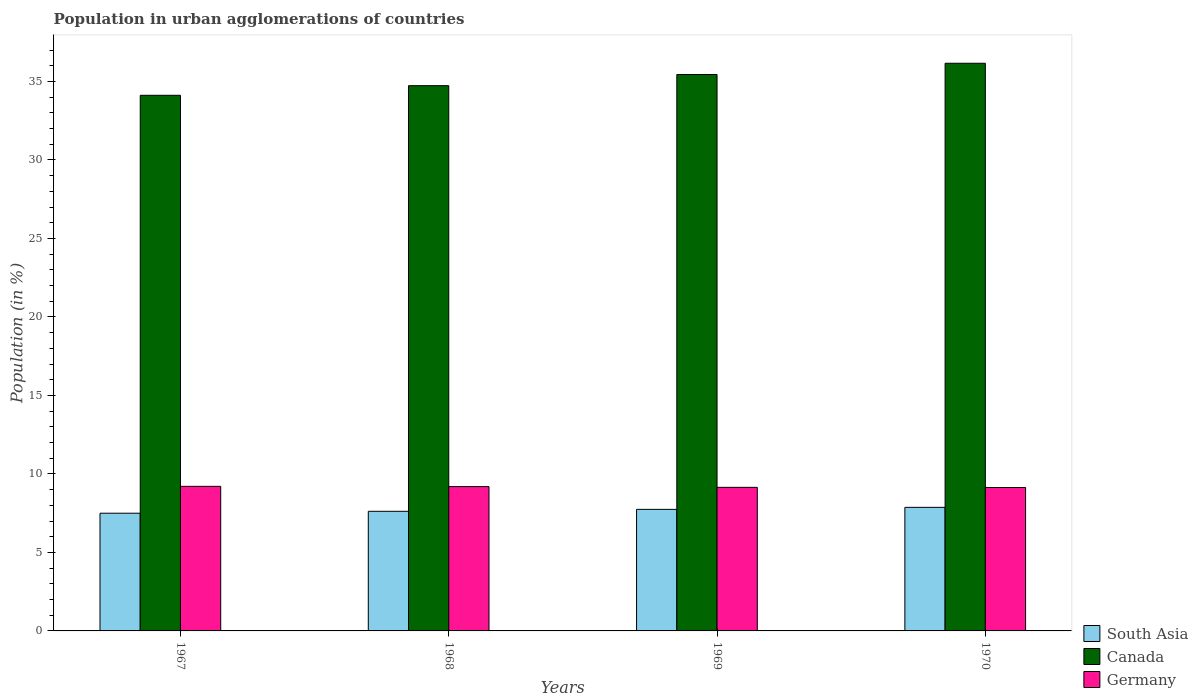Are the number of bars per tick equal to the number of legend labels?
Your response must be concise. Yes. Are the number of bars on each tick of the X-axis equal?
Offer a very short reply. Yes. How many bars are there on the 4th tick from the left?
Your answer should be compact. 3. How many bars are there on the 1st tick from the right?
Provide a short and direct response. 3. What is the percentage of population in urban agglomerations in Germany in 1967?
Offer a terse response. 9.21. Across all years, what is the maximum percentage of population in urban agglomerations in Canada?
Provide a short and direct response. 36.16. Across all years, what is the minimum percentage of population in urban agglomerations in Canada?
Make the answer very short. 34.12. In which year was the percentage of population in urban agglomerations in Canada maximum?
Offer a very short reply. 1970. What is the total percentage of population in urban agglomerations in Canada in the graph?
Provide a short and direct response. 140.45. What is the difference between the percentage of population in urban agglomerations in Germany in 1969 and that in 1970?
Give a very brief answer. 0.01. What is the difference between the percentage of population in urban agglomerations in South Asia in 1969 and the percentage of population in urban agglomerations in Germany in 1967?
Offer a very short reply. -1.47. What is the average percentage of population in urban agglomerations in South Asia per year?
Make the answer very short. 7.68. In the year 1968, what is the difference between the percentage of population in urban agglomerations in South Asia and percentage of population in urban agglomerations in Germany?
Make the answer very short. -1.57. What is the ratio of the percentage of population in urban agglomerations in Germany in 1968 to that in 1970?
Offer a very short reply. 1.01. Is the difference between the percentage of population in urban agglomerations in South Asia in 1968 and 1970 greater than the difference between the percentage of population in urban agglomerations in Germany in 1968 and 1970?
Make the answer very short. No. What is the difference between the highest and the second highest percentage of population in urban agglomerations in South Asia?
Ensure brevity in your answer.  0.13. What is the difference between the highest and the lowest percentage of population in urban agglomerations in Germany?
Give a very brief answer. 0.07. Is the sum of the percentage of population in urban agglomerations in Germany in 1968 and 1970 greater than the maximum percentage of population in urban agglomerations in Canada across all years?
Your response must be concise. No. What is the difference between two consecutive major ticks on the Y-axis?
Your answer should be compact. 5. Are the values on the major ticks of Y-axis written in scientific E-notation?
Provide a succinct answer. No. Does the graph contain any zero values?
Ensure brevity in your answer.  No. What is the title of the graph?
Provide a succinct answer. Population in urban agglomerations of countries. Does "Moldova" appear as one of the legend labels in the graph?
Offer a very short reply. No. What is the Population (in %) in South Asia in 1967?
Your answer should be very brief. 7.5. What is the Population (in %) in Canada in 1967?
Offer a very short reply. 34.12. What is the Population (in %) in Germany in 1967?
Provide a succinct answer. 9.21. What is the Population (in %) of South Asia in 1968?
Offer a very short reply. 7.62. What is the Population (in %) of Canada in 1968?
Provide a succinct answer. 34.73. What is the Population (in %) in Germany in 1968?
Keep it short and to the point. 9.19. What is the Population (in %) of South Asia in 1969?
Offer a very short reply. 7.74. What is the Population (in %) in Canada in 1969?
Your answer should be compact. 35.44. What is the Population (in %) of Germany in 1969?
Keep it short and to the point. 9.15. What is the Population (in %) in South Asia in 1970?
Your answer should be very brief. 7.87. What is the Population (in %) in Canada in 1970?
Your answer should be compact. 36.16. What is the Population (in %) of Germany in 1970?
Provide a succinct answer. 9.14. Across all years, what is the maximum Population (in %) of South Asia?
Make the answer very short. 7.87. Across all years, what is the maximum Population (in %) of Canada?
Provide a short and direct response. 36.16. Across all years, what is the maximum Population (in %) of Germany?
Your answer should be very brief. 9.21. Across all years, what is the minimum Population (in %) of South Asia?
Provide a short and direct response. 7.5. Across all years, what is the minimum Population (in %) in Canada?
Give a very brief answer. 34.12. Across all years, what is the minimum Population (in %) of Germany?
Your answer should be compact. 9.14. What is the total Population (in %) of South Asia in the graph?
Keep it short and to the point. 30.73. What is the total Population (in %) in Canada in the graph?
Provide a short and direct response. 140.45. What is the total Population (in %) of Germany in the graph?
Give a very brief answer. 36.68. What is the difference between the Population (in %) in South Asia in 1967 and that in 1968?
Keep it short and to the point. -0.12. What is the difference between the Population (in %) of Canada in 1967 and that in 1968?
Your answer should be very brief. -0.61. What is the difference between the Population (in %) of Germany in 1967 and that in 1968?
Your answer should be compact. 0.02. What is the difference between the Population (in %) of South Asia in 1967 and that in 1969?
Your answer should be very brief. -0.25. What is the difference between the Population (in %) in Canada in 1967 and that in 1969?
Offer a very short reply. -1.32. What is the difference between the Population (in %) of Germany in 1967 and that in 1969?
Offer a very short reply. 0.06. What is the difference between the Population (in %) in South Asia in 1967 and that in 1970?
Ensure brevity in your answer.  -0.37. What is the difference between the Population (in %) of Canada in 1967 and that in 1970?
Offer a very short reply. -2.04. What is the difference between the Population (in %) of Germany in 1967 and that in 1970?
Keep it short and to the point. 0.07. What is the difference between the Population (in %) of South Asia in 1968 and that in 1969?
Offer a very short reply. -0.12. What is the difference between the Population (in %) of Canada in 1968 and that in 1969?
Provide a short and direct response. -0.71. What is the difference between the Population (in %) of Germany in 1968 and that in 1969?
Give a very brief answer. 0.05. What is the difference between the Population (in %) in South Asia in 1968 and that in 1970?
Your response must be concise. -0.25. What is the difference between the Population (in %) in Canada in 1968 and that in 1970?
Your answer should be compact. -1.43. What is the difference between the Population (in %) of Germany in 1968 and that in 1970?
Make the answer very short. 0.06. What is the difference between the Population (in %) in South Asia in 1969 and that in 1970?
Offer a terse response. -0.13. What is the difference between the Population (in %) of Canada in 1969 and that in 1970?
Make the answer very short. -0.72. What is the difference between the Population (in %) of Germany in 1969 and that in 1970?
Your answer should be very brief. 0.01. What is the difference between the Population (in %) of South Asia in 1967 and the Population (in %) of Canada in 1968?
Provide a succinct answer. -27.23. What is the difference between the Population (in %) of South Asia in 1967 and the Population (in %) of Germany in 1968?
Keep it short and to the point. -1.7. What is the difference between the Population (in %) in Canada in 1967 and the Population (in %) in Germany in 1968?
Offer a very short reply. 24.93. What is the difference between the Population (in %) in South Asia in 1967 and the Population (in %) in Canada in 1969?
Offer a terse response. -27.94. What is the difference between the Population (in %) of South Asia in 1967 and the Population (in %) of Germany in 1969?
Keep it short and to the point. -1.65. What is the difference between the Population (in %) in Canada in 1967 and the Population (in %) in Germany in 1969?
Your answer should be compact. 24.97. What is the difference between the Population (in %) of South Asia in 1967 and the Population (in %) of Canada in 1970?
Provide a short and direct response. -28.66. What is the difference between the Population (in %) in South Asia in 1967 and the Population (in %) in Germany in 1970?
Ensure brevity in your answer.  -1.64. What is the difference between the Population (in %) in Canada in 1967 and the Population (in %) in Germany in 1970?
Your answer should be compact. 24.98. What is the difference between the Population (in %) of South Asia in 1968 and the Population (in %) of Canada in 1969?
Offer a very short reply. -27.82. What is the difference between the Population (in %) in South Asia in 1968 and the Population (in %) in Germany in 1969?
Ensure brevity in your answer.  -1.53. What is the difference between the Population (in %) of Canada in 1968 and the Population (in %) of Germany in 1969?
Your answer should be compact. 25.59. What is the difference between the Population (in %) of South Asia in 1968 and the Population (in %) of Canada in 1970?
Offer a terse response. -28.54. What is the difference between the Population (in %) of South Asia in 1968 and the Population (in %) of Germany in 1970?
Offer a terse response. -1.52. What is the difference between the Population (in %) of Canada in 1968 and the Population (in %) of Germany in 1970?
Your answer should be very brief. 25.59. What is the difference between the Population (in %) in South Asia in 1969 and the Population (in %) in Canada in 1970?
Offer a terse response. -28.42. What is the difference between the Population (in %) of South Asia in 1969 and the Population (in %) of Germany in 1970?
Your response must be concise. -1.39. What is the difference between the Population (in %) in Canada in 1969 and the Population (in %) in Germany in 1970?
Provide a succinct answer. 26.31. What is the average Population (in %) in South Asia per year?
Provide a short and direct response. 7.68. What is the average Population (in %) of Canada per year?
Give a very brief answer. 35.11. What is the average Population (in %) of Germany per year?
Offer a terse response. 9.17. In the year 1967, what is the difference between the Population (in %) in South Asia and Population (in %) in Canada?
Provide a succinct answer. -26.62. In the year 1967, what is the difference between the Population (in %) of South Asia and Population (in %) of Germany?
Your answer should be compact. -1.71. In the year 1967, what is the difference between the Population (in %) of Canada and Population (in %) of Germany?
Provide a short and direct response. 24.91. In the year 1968, what is the difference between the Population (in %) of South Asia and Population (in %) of Canada?
Provide a short and direct response. -27.11. In the year 1968, what is the difference between the Population (in %) in South Asia and Population (in %) in Germany?
Give a very brief answer. -1.57. In the year 1968, what is the difference between the Population (in %) in Canada and Population (in %) in Germany?
Give a very brief answer. 25.54. In the year 1969, what is the difference between the Population (in %) in South Asia and Population (in %) in Canada?
Give a very brief answer. -27.7. In the year 1969, what is the difference between the Population (in %) of South Asia and Population (in %) of Germany?
Your answer should be very brief. -1.4. In the year 1969, what is the difference between the Population (in %) of Canada and Population (in %) of Germany?
Provide a short and direct response. 26.3. In the year 1970, what is the difference between the Population (in %) of South Asia and Population (in %) of Canada?
Offer a terse response. -28.29. In the year 1970, what is the difference between the Population (in %) in South Asia and Population (in %) in Germany?
Your answer should be compact. -1.27. In the year 1970, what is the difference between the Population (in %) of Canada and Population (in %) of Germany?
Your response must be concise. 27.02. What is the ratio of the Population (in %) of South Asia in 1967 to that in 1968?
Your answer should be compact. 0.98. What is the ratio of the Population (in %) in Canada in 1967 to that in 1968?
Your answer should be very brief. 0.98. What is the ratio of the Population (in %) in South Asia in 1967 to that in 1969?
Offer a terse response. 0.97. What is the ratio of the Population (in %) in Canada in 1967 to that in 1969?
Ensure brevity in your answer.  0.96. What is the ratio of the Population (in %) of Germany in 1967 to that in 1969?
Keep it short and to the point. 1.01. What is the ratio of the Population (in %) of South Asia in 1967 to that in 1970?
Make the answer very short. 0.95. What is the ratio of the Population (in %) in Canada in 1967 to that in 1970?
Offer a very short reply. 0.94. What is the ratio of the Population (in %) of Germany in 1967 to that in 1970?
Provide a short and direct response. 1.01. What is the ratio of the Population (in %) in Canada in 1968 to that in 1969?
Offer a terse response. 0.98. What is the ratio of the Population (in %) in Canada in 1968 to that in 1970?
Provide a succinct answer. 0.96. What is the ratio of the Population (in %) of Germany in 1968 to that in 1970?
Provide a succinct answer. 1.01. What is the ratio of the Population (in %) of South Asia in 1969 to that in 1970?
Give a very brief answer. 0.98. What is the ratio of the Population (in %) of Canada in 1969 to that in 1970?
Your answer should be very brief. 0.98. What is the ratio of the Population (in %) of Germany in 1969 to that in 1970?
Provide a succinct answer. 1. What is the difference between the highest and the second highest Population (in %) of South Asia?
Provide a short and direct response. 0.13. What is the difference between the highest and the second highest Population (in %) in Canada?
Give a very brief answer. 0.72. What is the difference between the highest and the second highest Population (in %) of Germany?
Offer a very short reply. 0.02. What is the difference between the highest and the lowest Population (in %) in South Asia?
Make the answer very short. 0.37. What is the difference between the highest and the lowest Population (in %) of Canada?
Offer a terse response. 2.04. What is the difference between the highest and the lowest Population (in %) in Germany?
Make the answer very short. 0.07. 